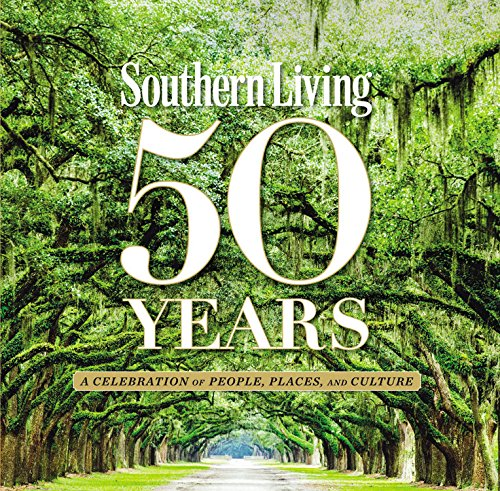Is this a motivational book? No, it is not a motivational book. Instead, it focuses on celebrating the rich culinary and cultural heritage of the Southern United States through recipes and stories. 